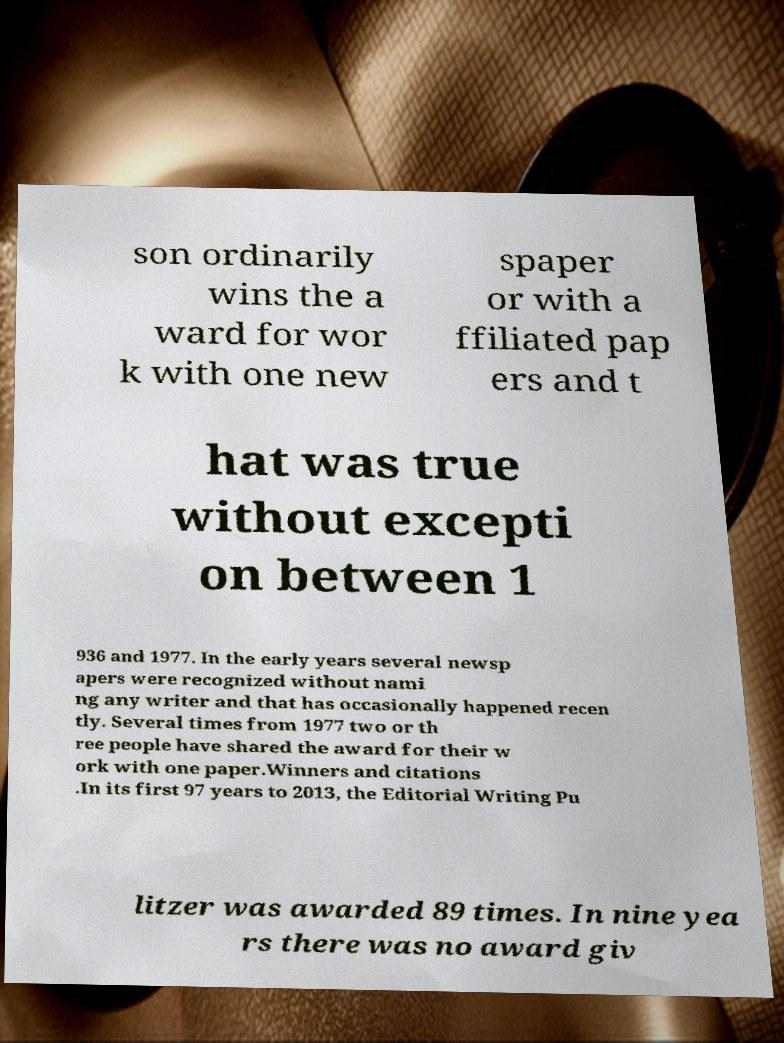What messages or text are displayed in this image? I need them in a readable, typed format. son ordinarily wins the a ward for wor k with one new spaper or with a ffiliated pap ers and t hat was true without excepti on between 1 936 and 1977. In the early years several newsp apers were recognized without nami ng any writer and that has occasionally happened recen tly. Several times from 1977 two or th ree people have shared the award for their w ork with one paper.Winners and citations .In its first 97 years to 2013, the Editorial Writing Pu litzer was awarded 89 times. In nine yea rs there was no award giv 